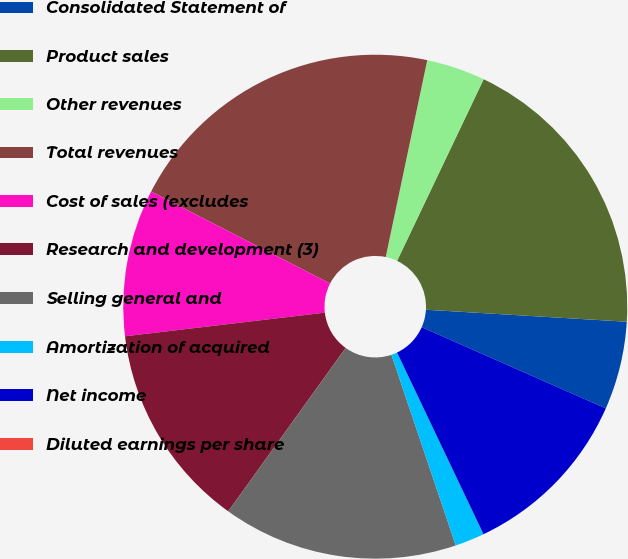Convert chart. <chart><loc_0><loc_0><loc_500><loc_500><pie_chart><fcel>Consolidated Statement of<fcel>Product sales<fcel>Other revenues<fcel>Total revenues<fcel>Cost of sales (excludes<fcel>Research and development (3)<fcel>Selling general and<fcel>Amortization of acquired<fcel>Net income<fcel>Diluted earnings per share<nl><fcel>5.66%<fcel>18.87%<fcel>3.77%<fcel>20.75%<fcel>9.43%<fcel>13.21%<fcel>15.09%<fcel>1.89%<fcel>11.32%<fcel>0.0%<nl></chart> 